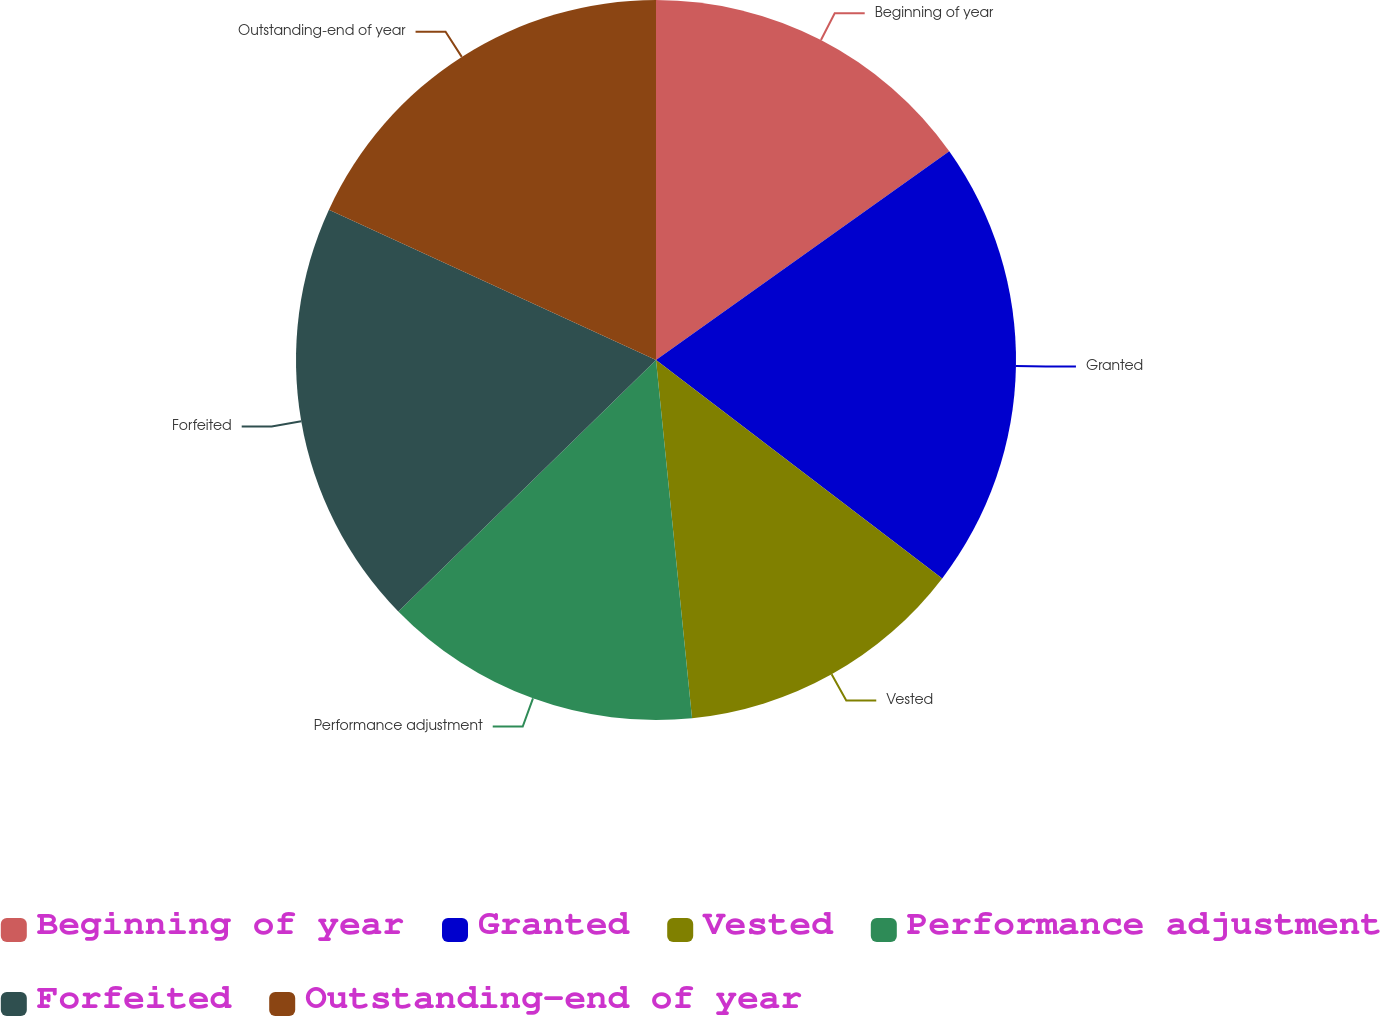Convert chart. <chart><loc_0><loc_0><loc_500><loc_500><pie_chart><fcel>Beginning of year<fcel>Granted<fcel>Vested<fcel>Performance adjustment<fcel>Forfeited<fcel>Outstanding-end of year<nl><fcel>15.15%<fcel>20.22%<fcel>13.03%<fcel>14.29%<fcel>19.16%<fcel>18.14%<nl></chart> 